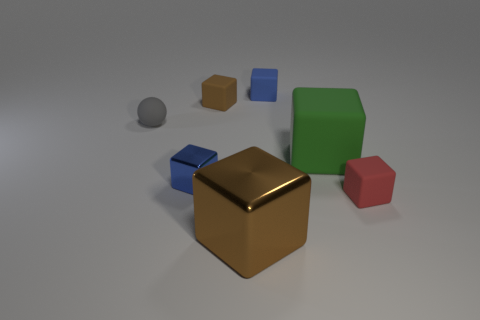Subtract 2 cubes. How many cubes are left? 4 Subtract all red blocks. How many blocks are left? 5 Subtract all small blue metallic cubes. How many cubes are left? 5 Subtract all green cubes. Subtract all purple spheres. How many cubes are left? 5 Add 1 tiny brown rubber objects. How many objects exist? 8 Subtract all balls. How many objects are left? 6 Add 4 tiny blue metal cubes. How many tiny blue metal cubes exist? 5 Subtract 0 yellow cylinders. How many objects are left? 7 Subtract all big blue cylinders. Subtract all green blocks. How many objects are left? 6 Add 7 tiny gray matte spheres. How many tiny gray matte spheres are left? 8 